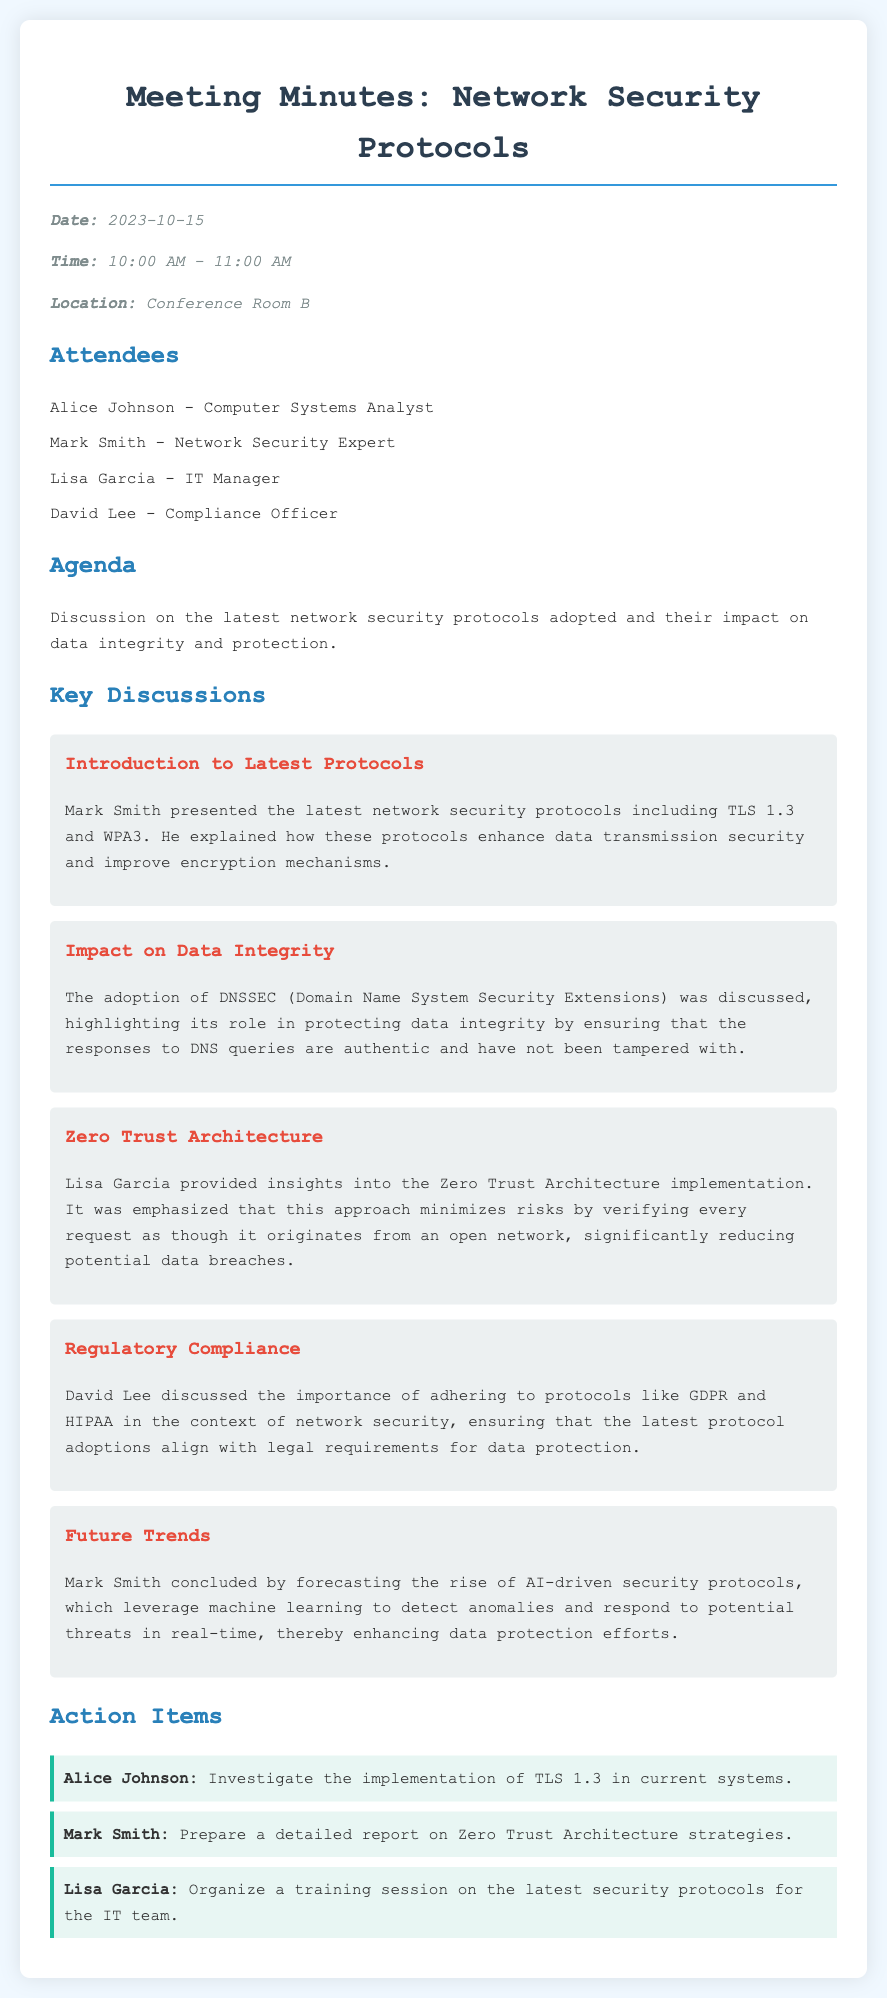What is the date of the meeting? The date of the meeting is mentioned in the document's meta-info section.
Answer: 2023-10-15 Who presented the latest network security protocols? The document specifies that Mark Smith presented the latest network security protocols during the meeting.
Answer: Mark Smith What protocol was discussed for protecting data integrity? The document indicates that DNSSEC was discussed regarding its role in protecting data integrity.
Answer: DNSSEC What is the approach emphasized by Lisa Garcia for minimizing risks? The document outlines that Lisa Garcia emphasized the Zero Trust Architecture for minimizing risks.
Answer: Zero Trust Architecture How long did the meeting last? The duration of the meeting can be calculated from the start and end times provided in the meta-info.
Answer: 1 hour Which regulation was mentioned in the context of network security? The document states that GDPR and HIPAA were discussed as important protocols for regulatory compliance.
Answer: GDPR and HIPAA What was an action item assigned to Alice Johnson? The document lists the action items and specifies that Alice Johnson is to investigate the implementation of TLS 1.3.
Answer: Investigate the implementation of TLS 1.3 What future trend did Mark Smith advocate for? The document notes that Mark Smith forecasted the rise of AI-driven security protocols as a future trend in network security.
Answer: AI-driven security protocols 